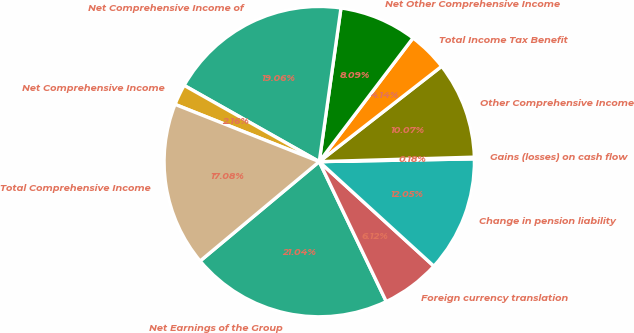<chart> <loc_0><loc_0><loc_500><loc_500><pie_chart><fcel>Net Earnings of the Group<fcel>Foreign currency translation<fcel>Change in pension liability<fcel>Gains (losses) on cash flow<fcel>Other Comprehensive Income<fcel>Total Income Tax Benefit<fcel>Net Other Comprehensive Income<fcel>Net Comprehensive Income of<fcel>Net Comprehensive Income<fcel>Total Comprehensive Income<nl><fcel>21.04%<fcel>6.12%<fcel>12.05%<fcel>0.18%<fcel>10.07%<fcel>4.14%<fcel>8.09%<fcel>19.06%<fcel>2.16%<fcel>17.08%<nl></chart> 